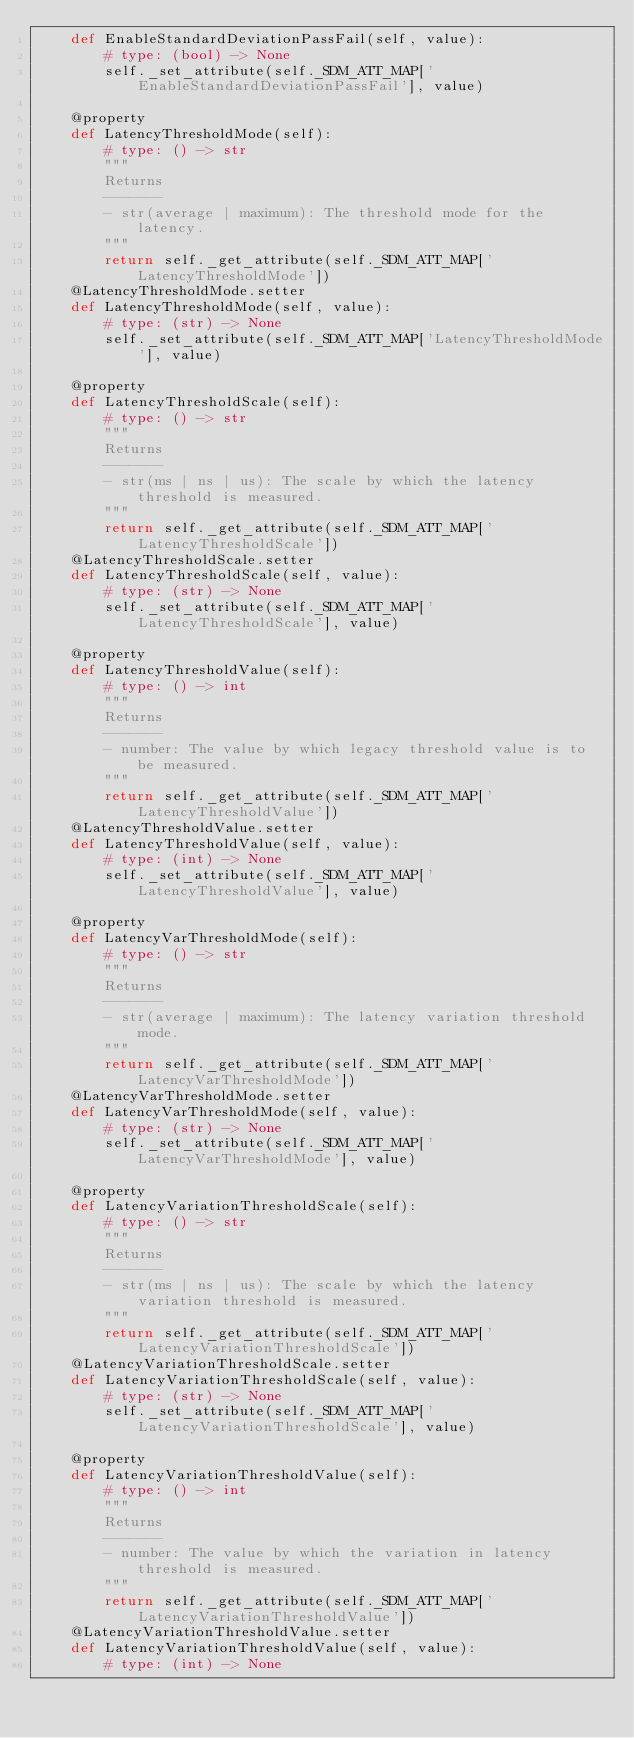<code> <loc_0><loc_0><loc_500><loc_500><_Python_>    def EnableStandardDeviationPassFail(self, value):
        # type: (bool) -> None
        self._set_attribute(self._SDM_ATT_MAP['EnableStandardDeviationPassFail'], value)

    @property
    def LatencyThresholdMode(self):
        # type: () -> str
        """
        Returns
        -------
        - str(average | maximum): The threshold mode for the latency.
        """
        return self._get_attribute(self._SDM_ATT_MAP['LatencyThresholdMode'])
    @LatencyThresholdMode.setter
    def LatencyThresholdMode(self, value):
        # type: (str) -> None
        self._set_attribute(self._SDM_ATT_MAP['LatencyThresholdMode'], value)

    @property
    def LatencyThresholdScale(self):
        # type: () -> str
        """
        Returns
        -------
        - str(ms | ns | us): The scale by which the latency threshold is measured.
        """
        return self._get_attribute(self._SDM_ATT_MAP['LatencyThresholdScale'])
    @LatencyThresholdScale.setter
    def LatencyThresholdScale(self, value):
        # type: (str) -> None
        self._set_attribute(self._SDM_ATT_MAP['LatencyThresholdScale'], value)

    @property
    def LatencyThresholdValue(self):
        # type: () -> int
        """
        Returns
        -------
        - number: The value by which legacy threshold value is to be measured.
        """
        return self._get_attribute(self._SDM_ATT_MAP['LatencyThresholdValue'])
    @LatencyThresholdValue.setter
    def LatencyThresholdValue(self, value):
        # type: (int) -> None
        self._set_attribute(self._SDM_ATT_MAP['LatencyThresholdValue'], value)

    @property
    def LatencyVarThresholdMode(self):
        # type: () -> str
        """
        Returns
        -------
        - str(average | maximum): The latency variation threshold mode.
        """
        return self._get_attribute(self._SDM_ATT_MAP['LatencyVarThresholdMode'])
    @LatencyVarThresholdMode.setter
    def LatencyVarThresholdMode(self, value):
        # type: (str) -> None
        self._set_attribute(self._SDM_ATT_MAP['LatencyVarThresholdMode'], value)

    @property
    def LatencyVariationThresholdScale(self):
        # type: () -> str
        """
        Returns
        -------
        - str(ms | ns | us): The scale by which the latency variation threshold is measured.
        """
        return self._get_attribute(self._SDM_ATT_MAP['LatencyVariationThresholdScale'])
    @LatencyVariationThresholdScale.setter
    def LatencyVariationThresholdScale(self, value):
        # type: (str) -> None
        self._set_attribute(self._SDM_ATT_MAP['LatencyVariationThresholdScale'], value)

    @property
    def LatencyVariationThresholdValue(self):
        # type: () -> int
        """
        Returns
        -------
        - number: The value by which the variation in latency threshold is measured.
        """
        return self._get_attribute(self._SDM_ATT_MAP['LatencyVariationThresholdValue'])
    @LatencyVariationThresholdValue.setter
    def LatencyVariationThresholdValue(self, value):
        # type: (int) -> None</code> 